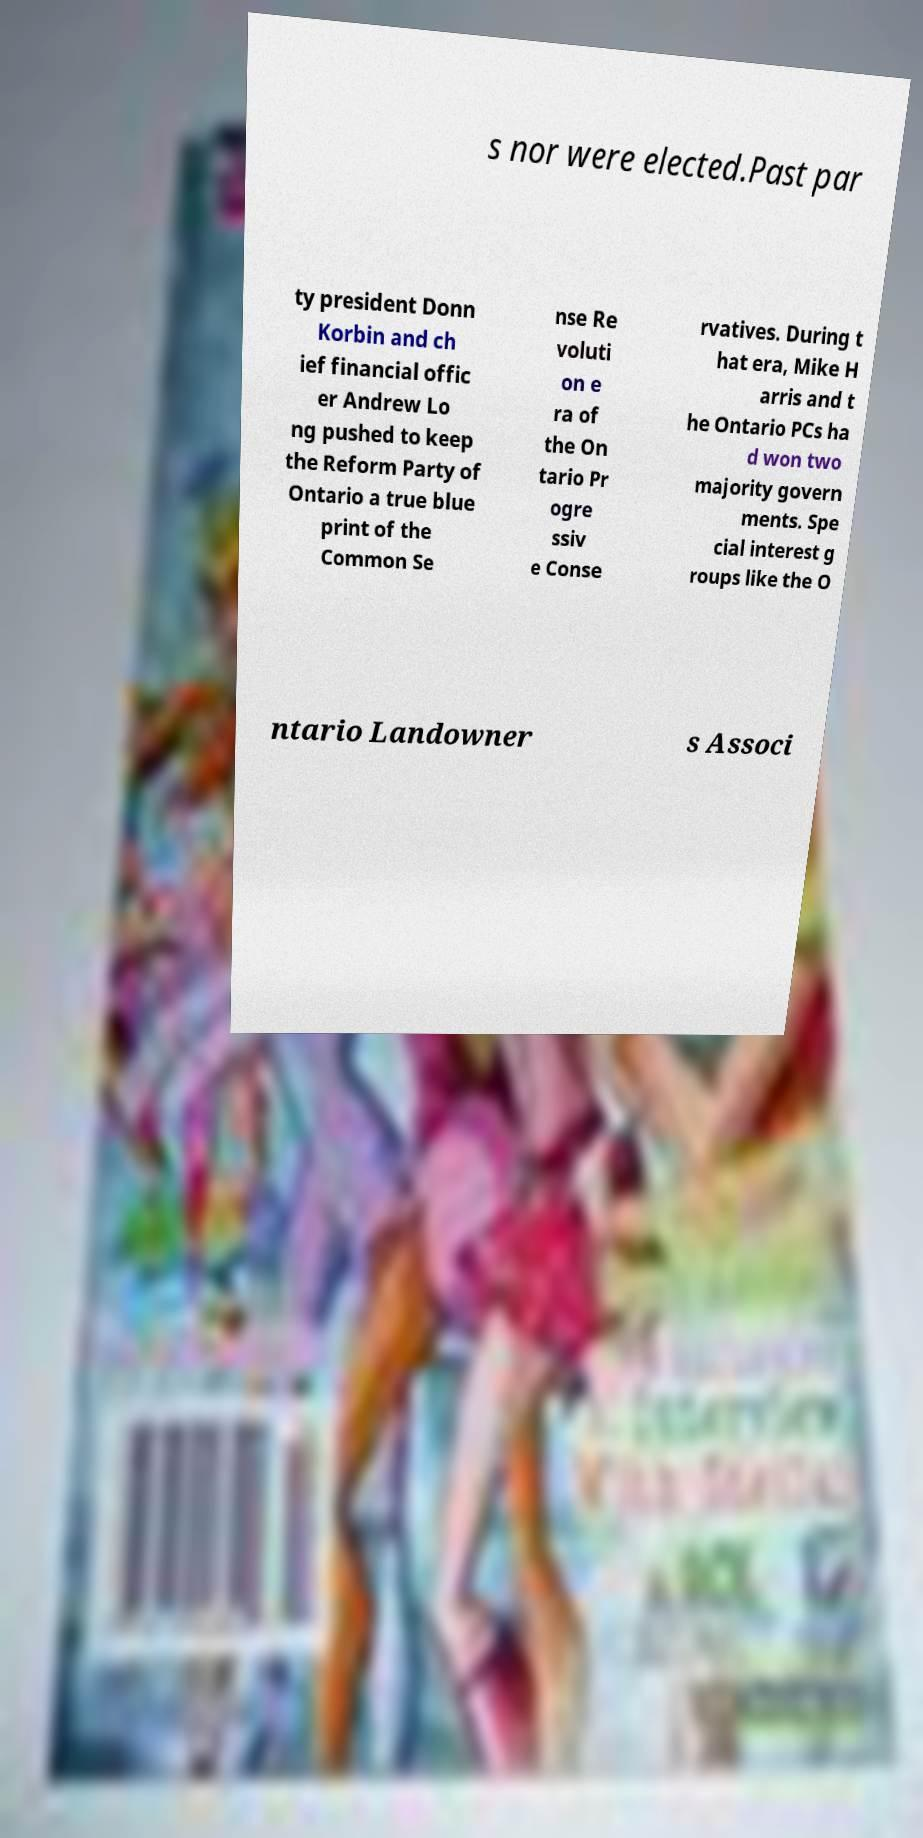Can you accurately transcribe the text from the provided image for me? s nor were elected.Past par ty president Donn Korbin and ch ief financial offic er Andrew Lo ng pushed to keep the Reform Party of Ontario a true blue print of the Common Se nse Re voluti on e ra of the On tario Pr ogre ssiv e Conse rvatives. During t hat era, Mike H arris and t he Ontario PCs ha d won two majority govern ments. Spe cial interest g roups like the O ntario Landowner s Associ 